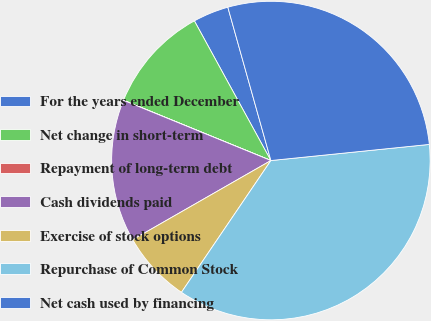<chart> <loc_0><loc_0><loc_500><loc_500><pie_chart><fcel>For the years ended December<fcel>Net change in short-term<fcel>Repayment of long-term debt<fcel>Cash dividends paid<fcel>Exercise of stock options<fcel>Repurchase of Common Stock<fcel>Net cash used by financing<nl><fcel>3.62%<fcel>10.84%<fcel>0.01%<fcel>14.45%<fcel>7.23%<fcel>36.1%<fcel>27.74%<nl></chart> 